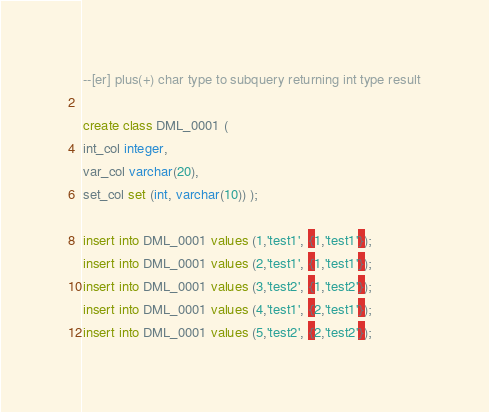<code> <loc_0><loc_0><loc_500><loc_500><_SQL_>--[er] plus(+) char type to subquery returning int type result

create class DML_0001 ( 	
int_col integer,
var_col varchar(20),
set_col set (int, varchar(10)) );

insert into DML_0001 values (1,'test1', {1,'test1'});
insert into DML_0001 values (2,'test1', {1,'test1'});
insert into DML_0001 values (3,'test2', {1,'test2'});
insert into DML_0001 values (4,'test1', {2,'test1'});
insert into DML_0001 values (5,'test2', {2,'test2'});
</code> 